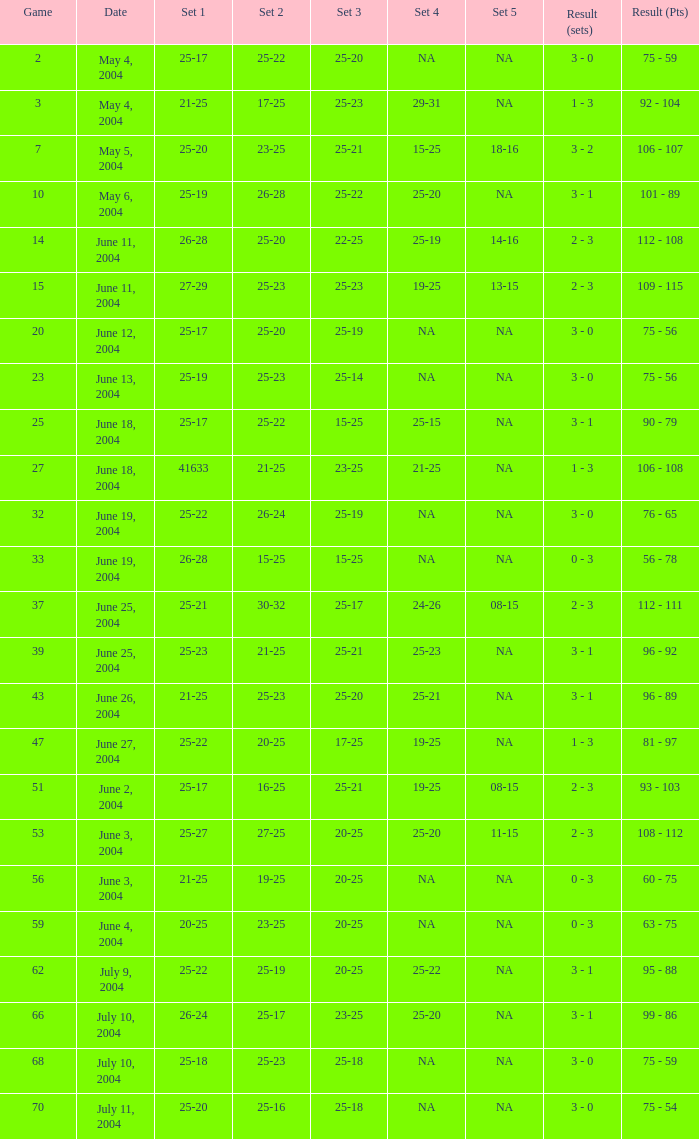What is the set 5 for the game with a set 2 of 21-25 and a set 1 of 41633? NA. 